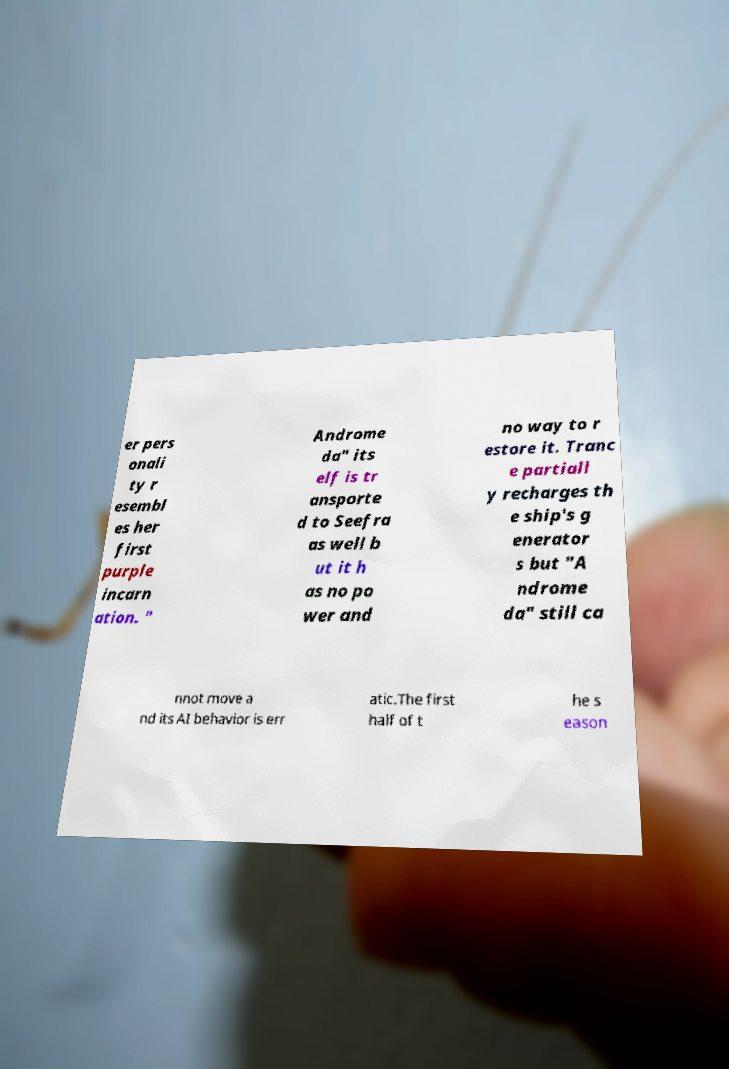Could you extract and type out the text from this image? er pers onali ty r esembl es her first purple incarn ation. " Androme da" its elf is tr ansporte d to Seefra as well b ut it h as no po wer and no way to r estore it. Tranc e partiall y recharges th e ship's g enerator s but "A ndrome da" still ca nnot move a nd its AI behavior is err atic.The first half of t he s eason 